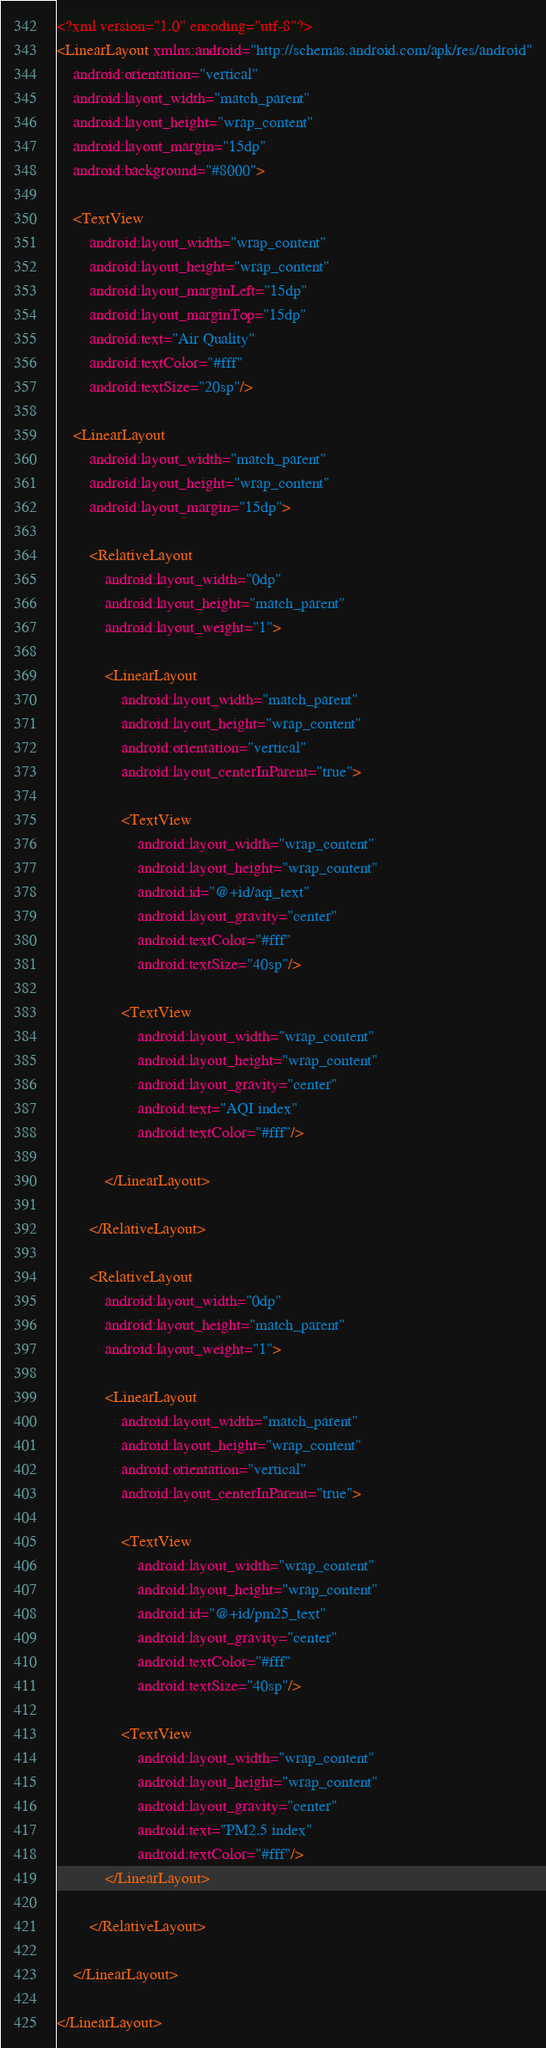Convert code to text. <code><loc_0><loc_0><loc_500><loc_500><_XML_><?xml version="1.0" encoding="utf-8"?>
<LinearLayout xmlns:android="http://schemas.android.com/apk/res/android"
    android:orientation="vertical"
    android:layout_width="match_parent"
    android:layout_height="wrap_content"
    android:layout_margin="15dp"
    android:background="#8000">

    <TextView
        android:layout_width="wrap_content"
        android:layout_height="wrap_content"
        android:layout_marginLeft="15dp"
        android:layout_marginTop="15dp"
        android:text="Air Quality"
        android:textColor="#fff"
        android:textSize="20sp"/>

    <LinearLayout
        android:layout_width="match_parent"
        android:layout_height="wrap_content"
        android:layout_margin="15dp">

        <RelativeLayout
            android:layout_width="0dp"
            android:layout_height="match_parent"
            android:layout_weight="1">

            <LinearLayout
                android:layout_width="match_parent"
                android:layout_height="wrap_content"
                android:orientation="vertical"
                android:layout_centerInParent="true">

                <TextView
                    android:layout_width="wrap_content"
                    android:layout_height="wrap_content"
                    android:id="@+id/aqi_text"
                    android:layout_gravity="center"
                    android:textColor="#fff"
                    android:textSize="40sp"/>

                <TextView
                    android:layout_width="wrap_content"
                    android:layout_height="wrap_content"
                    android:layout_gravity="center"
                    android:text="AQI index"
                    android:textColor="#fff"/>

            </LinearLayout>

        </RelativeLayout>

        <RelativeLayout
            android:layout_width="0dp"
            android:layout_height="match_parent"
            android:layout_weight="1">

            <LinearLayout
                android:layout_width="match_parent"
                android:layout_height="wrap_content"
                android:orientation="vertical"
                android:layout_centerInParent="true">

                <TextView
                    android:layout_width="wrap_content"
                    android:layout_height="wrap_content"
                    android:id="@+id/pm25_text"
                    android:layout_gravity="center"
                    android:textColor="#fff"
                    android:textSize="40sp"/>

                <TextView
                    android:layout_width="wrap_content"
                    android:layout_height="wrap_content"
                    android:layout_gravity="center"
                    android:text="PM2.5 index"
                    android:textColor="#fff"/>
            </LinearLayout>

        </RelativeLayout>

    </LinearLayout>

</LinearLayout></code> 